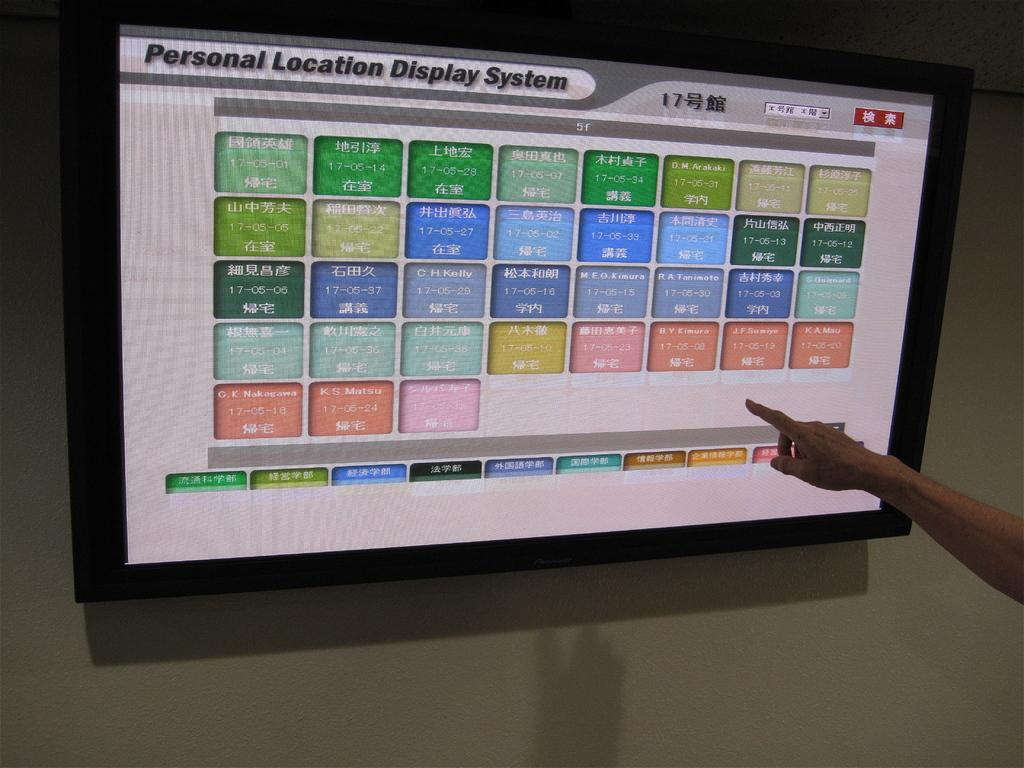<image>
Provide a brief description of the given image. Someone is pointing to a screen about personal location display system. 